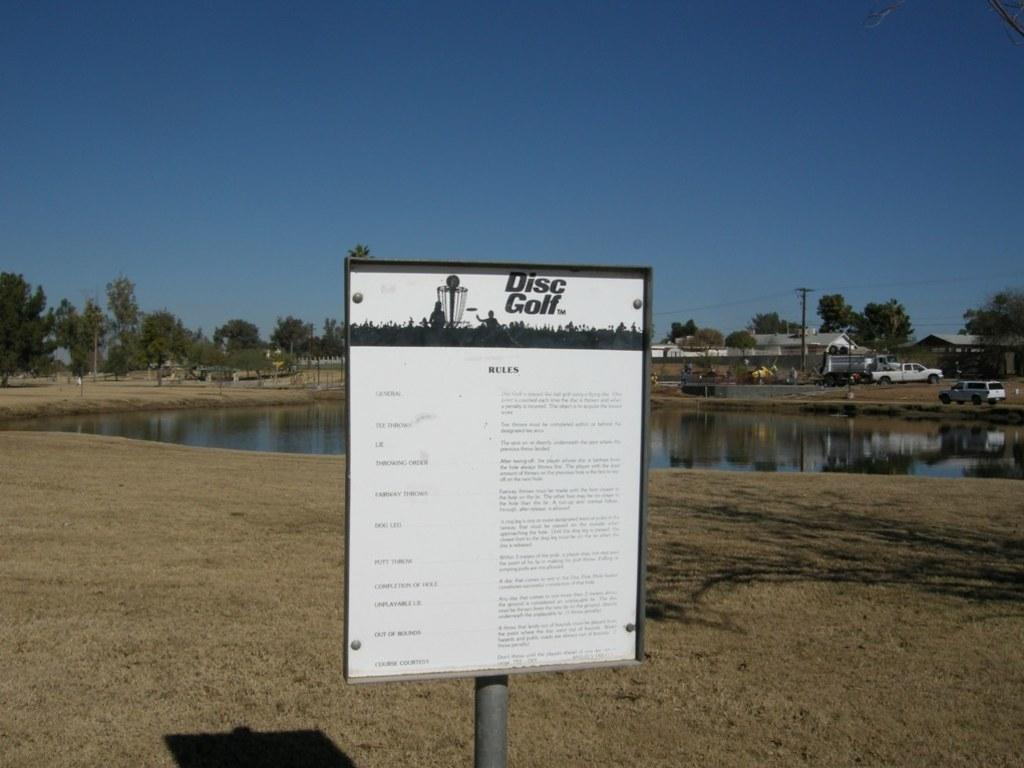What is written on the board in the image? The image contains a board with text, but the specific text is not mentioned in the facts. What is the primary element in the image? There is water in the image. What can be seen in the background of the image? There are trees, cars, and buildings in the background of the image. What type of flesh can be seen hanging from the trees in the image? There is no flesh present in the image; it features a board with text, water, and background elements such as trees, cars, and buildings. 